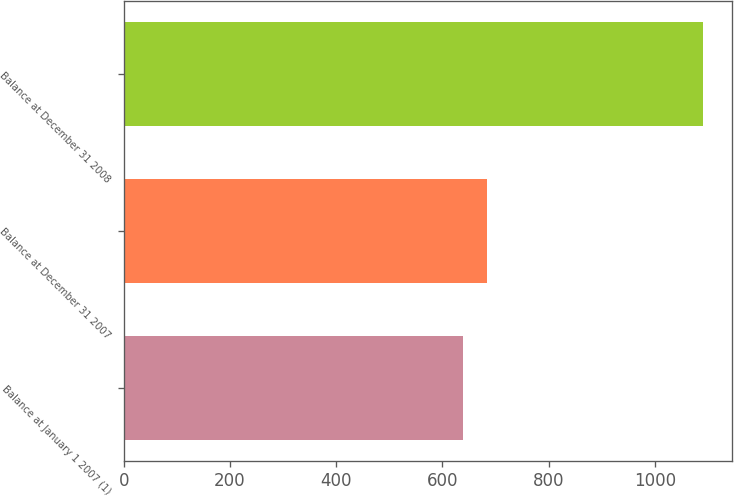<chart> <loc_0><loc_0><loc_500><loc_500><bar_chart><fcel>Balance at January 1 2007 (1)<fcel>Balance at December 31 2007<fcel>Balance at December 31 2008<nl><fcel>638<fcel>683.3<fcel>1091<nl></chart> 